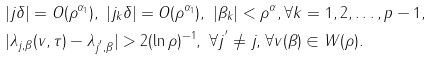<formula> <loc_0><loc_0><loc_500><loc_500>& | j \delta | = O ( \rho ^ { \alpha _ { 1 } } ) , \text { } | j _ { k } \delta | = O ( \rho ^ { \alpha _ { 1 } } ) , \text { } | \beta _ { k } | < \rho ^ { \alpha } , \forall k = 1 , 2 , \dots , p - 1 , \\ & | \lambda _ { j , \beta } ( v , \tau ) - \lambda _ { j ^ { ^ { \prime } } , \beta } | > 2 ( \ln \rho ) ^ { - 1 } , \text { } \forall j ^ { ^ { \prime } } \neq j \text {, } \forall v ( \beta ) \in W ( \rho ) .</formula> 